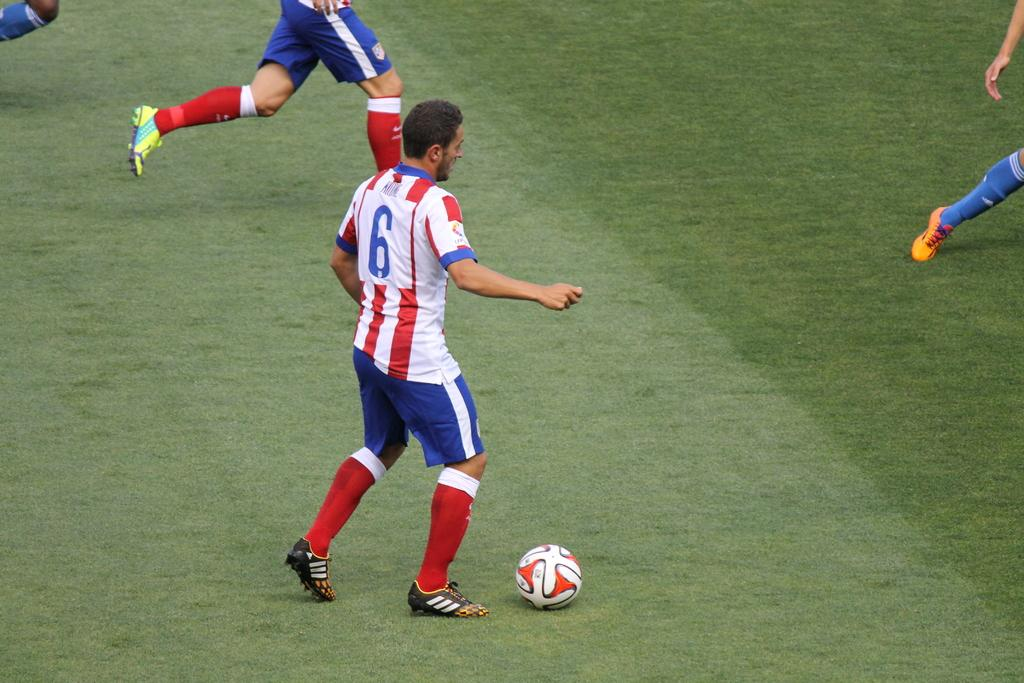<image>
Write a terse but informative summary of the picture. Number six gets ready to pass the ball to a teammate. 